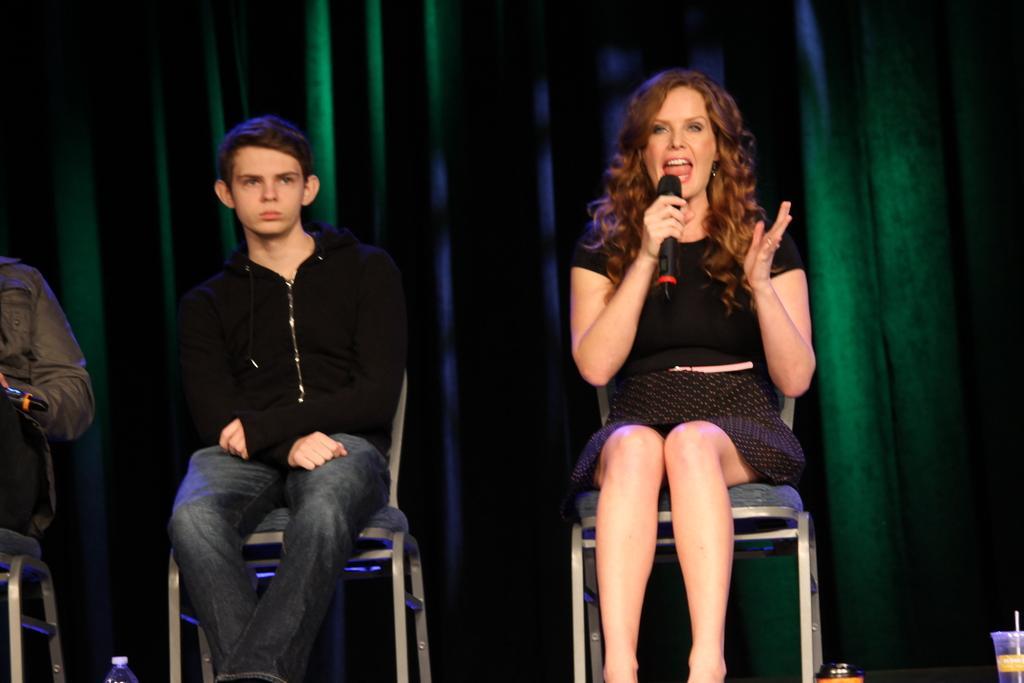How would you summarize this image in a sentence or two? In this image we can see three people sitting on the chairs, three objects on the bottom of the image, one green curtain in the background, one person holding an object on the left side of the image, three chairs, one woman holding a microphone and talking. 